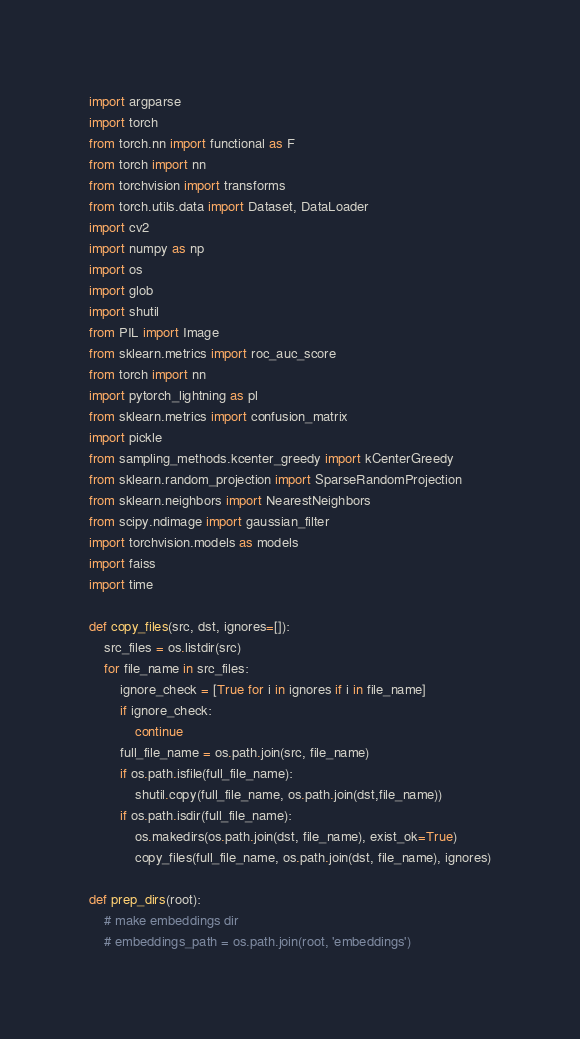<code> <loc_0><loc_0><loc_500><loc_500><_Python_>import argparse
import torch
from torch.nn import functional as F
from torch import nn
from torchvision import transforms
from torch.utils.data import Dataset, DataLoader
import cv2
import numpy as np
import os
import glob
import shutil
from PIL import Image
from sklearn.metrics import roc_auc_score
from torch import nn
import pytorch_lightning as pl
from sklearn.metrics import confusion_matrix
import pickle
from sampling_methods.kcenter_greedy import kCenterGreedy
from sklearn.random_projection import SparseRandomProjection
from sklearn.neighbors import NearestNeighbors
from scipy.ndimage import gaussian_filter
import torchvision.models as models
import faiss
import time 

def copy_files(src, dst, ignores=[]):
    src_files = os.listdir(src)
    for file_name in src_files:
        ignore_check = [True for i in ignores if i in file_name]
        if ignore_check:
            continue
        full_file_name = os.path.join(src, file_name)
        if os.path.isfile(full_file_name):
            shutil.copy(full_file_name, os.path.join(dst,file_name))
        if os.path.isdir(full_file_name):
            os.makedirs(os.path.join(dst, file_name), exist_ok=True)
            copy_files(full_file_name, os.path.join(dst, file_name), ignores)

def prep_dirs(root):
    # make embeddings dir
    # embeddings_path = os.path.join(root, 'embeddings')</code> 